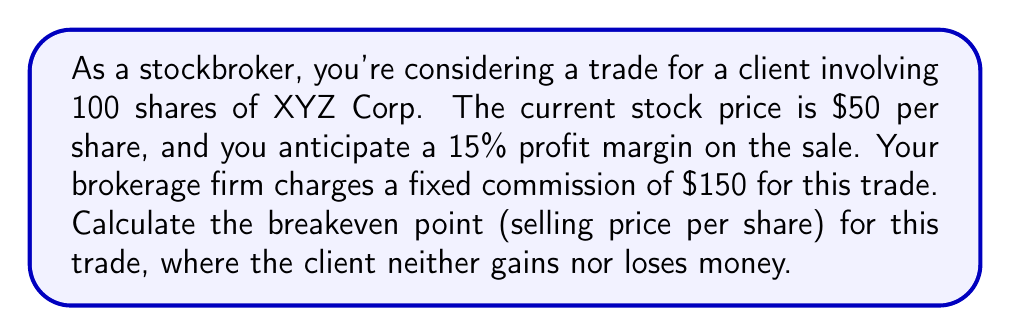Teach me how to tackle this problem. Let's approach this step-by-step:

1) First, let's define our variables:
   $x$ = breakeven selling price per share
   $n$ = number of shares = 100
   $p$ = purchase price per share = $50
   $m$ = profit margin = 15% = 0.15
   $c$ = fixed commission = $150

2) At the breakeven point, the total revenue equals the total cost:
   Total Revenue = Total Cost

3) Total Revenue is the selling price multiplied by the number of shares:
   $nx$

4) Total Cost includes the purchase cost, commission, and the desired profit margin:
   $n(p + mp) + c$

5) Setting up the equation:
   $nx = n(p + mp) + c$

6) Substituting the values:
   $100x = 100(50 + 0.15 * 50) + 150$

7) Simplifying:
   $100x = 100(50 + 7.50) + 150$
   $100x = 5750 + 150$
   $100x = 5900$

8) Solving for $x$:
   $x = \frac{5900}{100} = 59$

Therefore, the breakeven selling price per share is $59.
Answer: $59 per share 